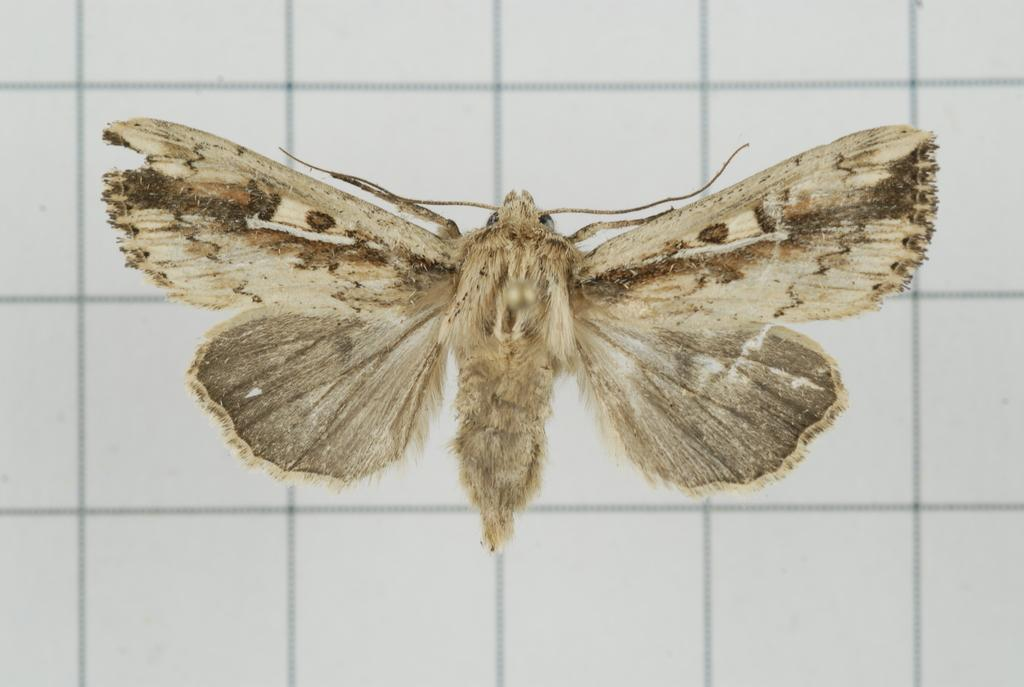What type of creature is present in the image? There is an insect in the image. What type of finger can be seen giving approval in the image? There is no finger or approval present in the image; it only features an insect. 